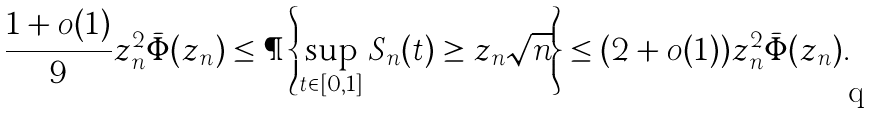<formula> <loc_0><loc_0><loc_500><loc_500>\frac { 1 + o ( 1 ) } { 9 } z _ { n } ^ { 2 } \bar { \Phi } ( z _ { n } ) \leq \P \left \{ \sup _ { t \in [ 0 , 1 ] } S _ { n } ( t ) \geq z _ { n } \sqrt { n } \right \} \leq ( 2 + o ( 1 ) ) z _ { n } ^ { 2 } \bar { \Phi } ( z _ { n } ) .</formula> 